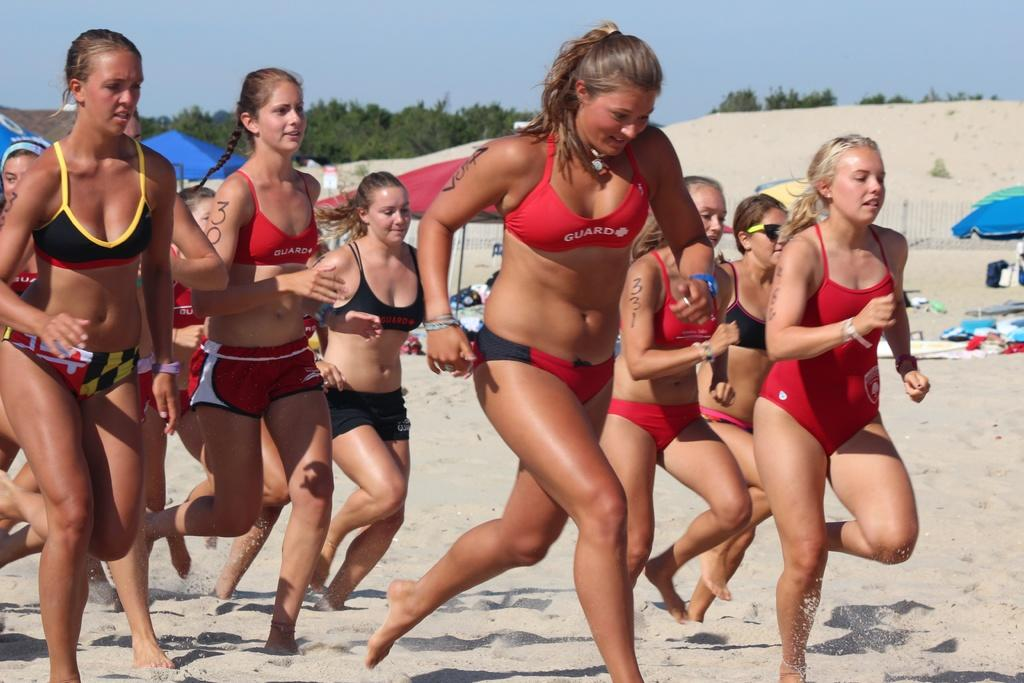<image>
Create a compact narrative representing the image presented. Women in bathing suits, printed with the word Guard, running on a beach. 